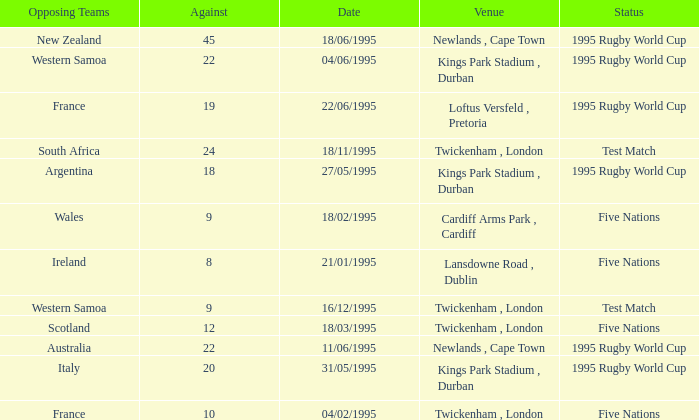What date has a status of 1995 rugby world cup and an against of 20? 31/05/1995. 